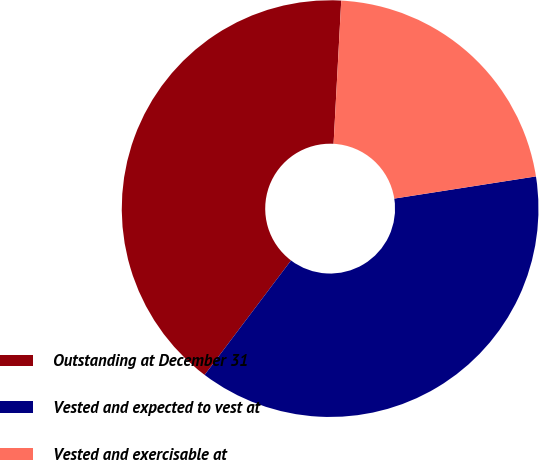<chart> <loc_0><loc_0><loc_500><loc_500><pie_chart><fcel>Outstanding at December 31<fcel>Vested and expected to vest at<fcel>Vested and exercisable at<nl><fcel>40.56%<fcel>37.76%<fcel>21.68%<nl></chart> 